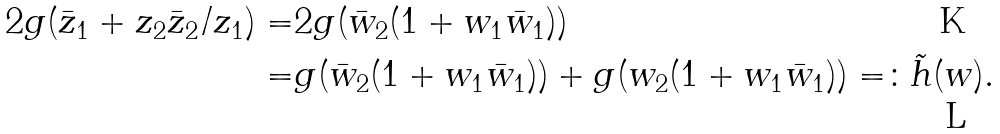<formula> <loc_0><loc_0><loc_500><loc_500>2 \real g ( \bar { z } _ { 1 } + z _ { 2 } \bar { z } _ { 2 } / z _ { 1 } ) = & 2 \real g ( \bar { w } _ { 2 } ( 1 + w _ { 1 } \bar { w } _ { 1 } ) ) \\ = & g ( \bar { w } _ { 2 } ( 1 + w _ { 1 } \bar { w } _ { 1 } ) ) + g ( w _ { 2 } ( 1 + w _ { 1 } \bar { w } _ { 1 } ) ) = \colon \tilde { h } ( w ) .</formula> 